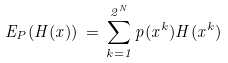Convert formula to latex. <formula><loc_0><loc_0><loc_500><loc_500>E _ { P } ( H ( x ) ) \, = \, \sum _ { k = 1 } ^ { 2 ^ { N } } p ( x ^ { k } ) H ( x ^ { k } )</formula> 